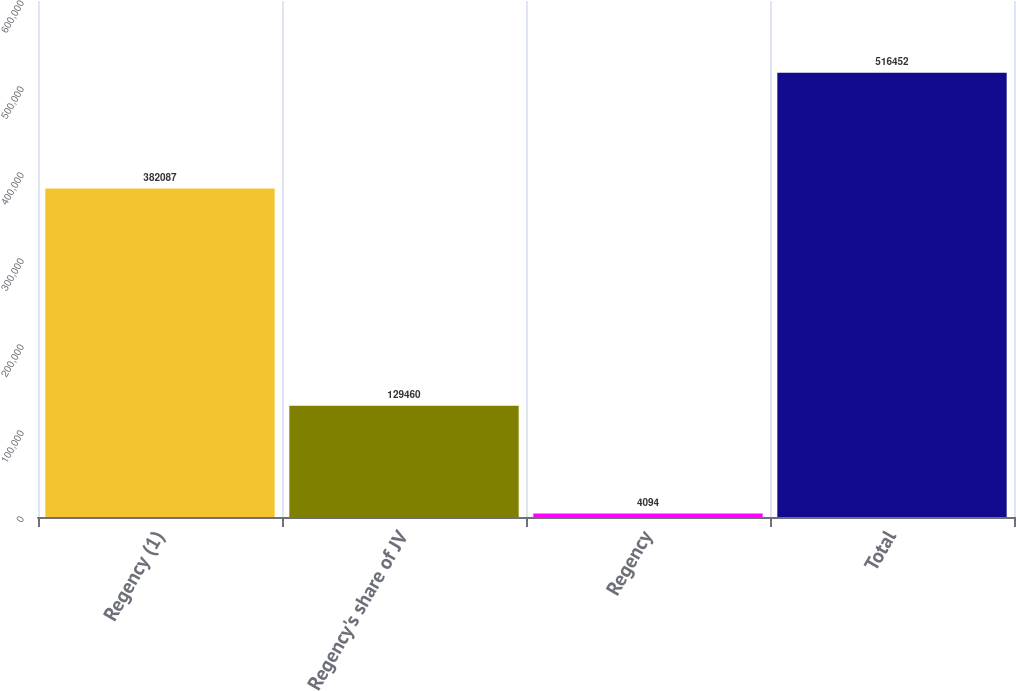<chart> <loc_0><loc_0><loc_500><loc_500><bar_chart><fcel>Regency (1)<fcel>Regency's share of JV<fcel>Regency<fcel>Total<nl><fcel>382087<fcel>129460<fcel>4094<fcel>516452<nl></chart> 